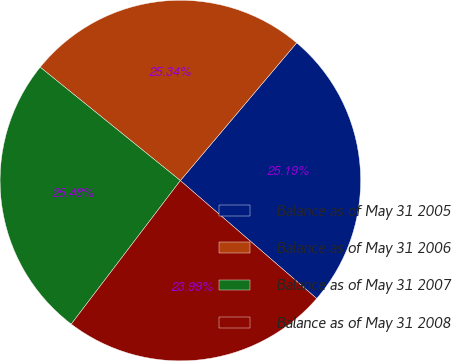<chart> <loc_0><loc_0><loc_500><loc_500><pie_chart><fcel>Balance as of May 31 2005<fcel>Balance as of May 31 2006<fcel>Balance as of May 31 2007<fcel>Balance as of May 31 2008<nl><fcel>25.19%<fcel>25.34%<fcel>25.48%<fcel>23.99%<nl></chart> 